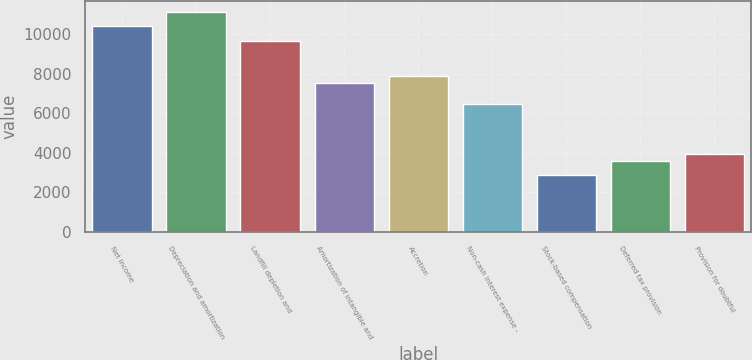<chart> <loc_0><loc_0><loc_500><loc_500><bar_chart><fcel>Net income<fcel>Depreciation and amortization<fcel>Landfill depletion and<fcel>Amortization of intangible and<fcel>Accretion<fcel>Non-cash interest expense -<fcel>Stock-based compensation<fcel>Deferred tax provision<fcel>Provision for doubtful<nl><fcel>10393.1<fcel>11109.9<fcel>9676.36<fcel>7526.08<fcel>7884.46<fcel>6450.94<fcel>2867.14<fcel>3583.9<fcel>3942.28<nl></chart> 